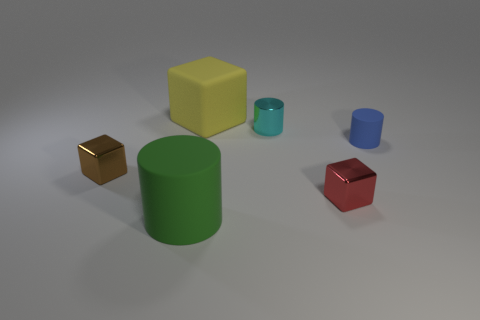Is there a block behind the tiny metallic thing behind the blue thing?
Offer a terse response. Yes. Are there any other things of the same color as the big rubber cylinder?
Ensure brevity in your answer.  No. Are the small thing left of the yellow block and the large yellow cube made of the same material?
Offer a very short reply. No. Are there the same number of tiny metal blocks behind the brown cube and tiny shiny cylinders that are left of the large green cylinder?
Make the answer very short. Yes. There is a metal object on the left side of the cyan object on the left side of the red metal object; what is its size?
Offer a very short reply. Small. There is a thing that is right of the large matte cube and behind the small blue rubber cylinder; what material is it?
Offer a terse response. Metal. What number of other things are the same size as the blue cylinder?
Your response must be concise. 3. What is the color of the small metal cylinder?
Your answer should be very brief. Cyan. There is a metallic thing on the left side of the green rubber thing; does it have the same color as the block behind the tiny brown metal block?
Make the answer very short. No. The rubber cube is what size?
Your answer should be very brief. Large. 